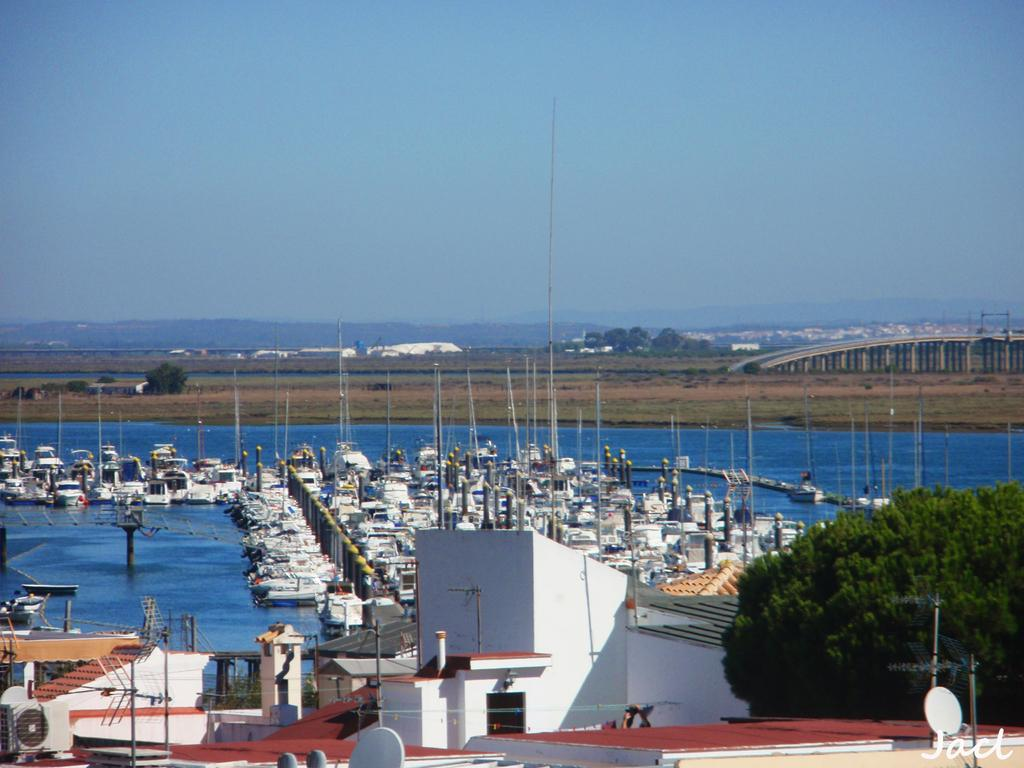What is in the water in the image? There are boats in the water in the image. What type of location is depicted in the image? There is a harbor in the image. What can be seen in the background of the image? There are trees in the image. What is the empty land with land with trees and other things in the image used for? The empty land with trees and other things in the image is not specified, but it could be a park or a recreational area. Where is the school located in the image? There is no school present in the image. Is there a trail visible in the image? There is no trail visible in the image. 